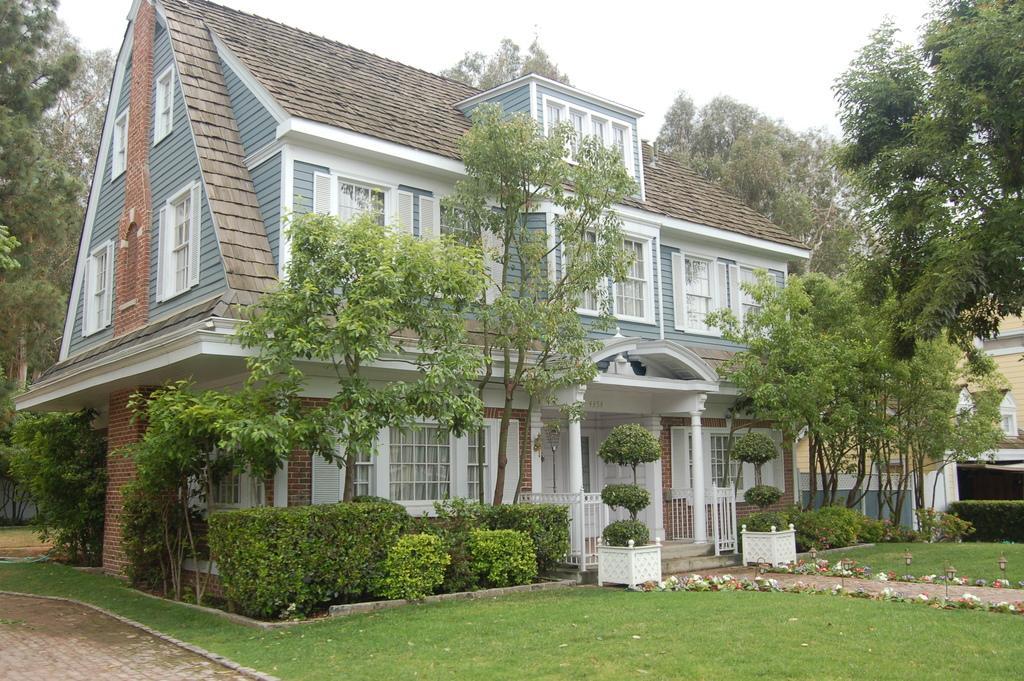Could you give a brief overview of what you see in this image? In this picture there are buildings and trees and there are plants. At the top there is sky. At the bottom there is grass and there is a railing and there are flowers and there is a pavement. 